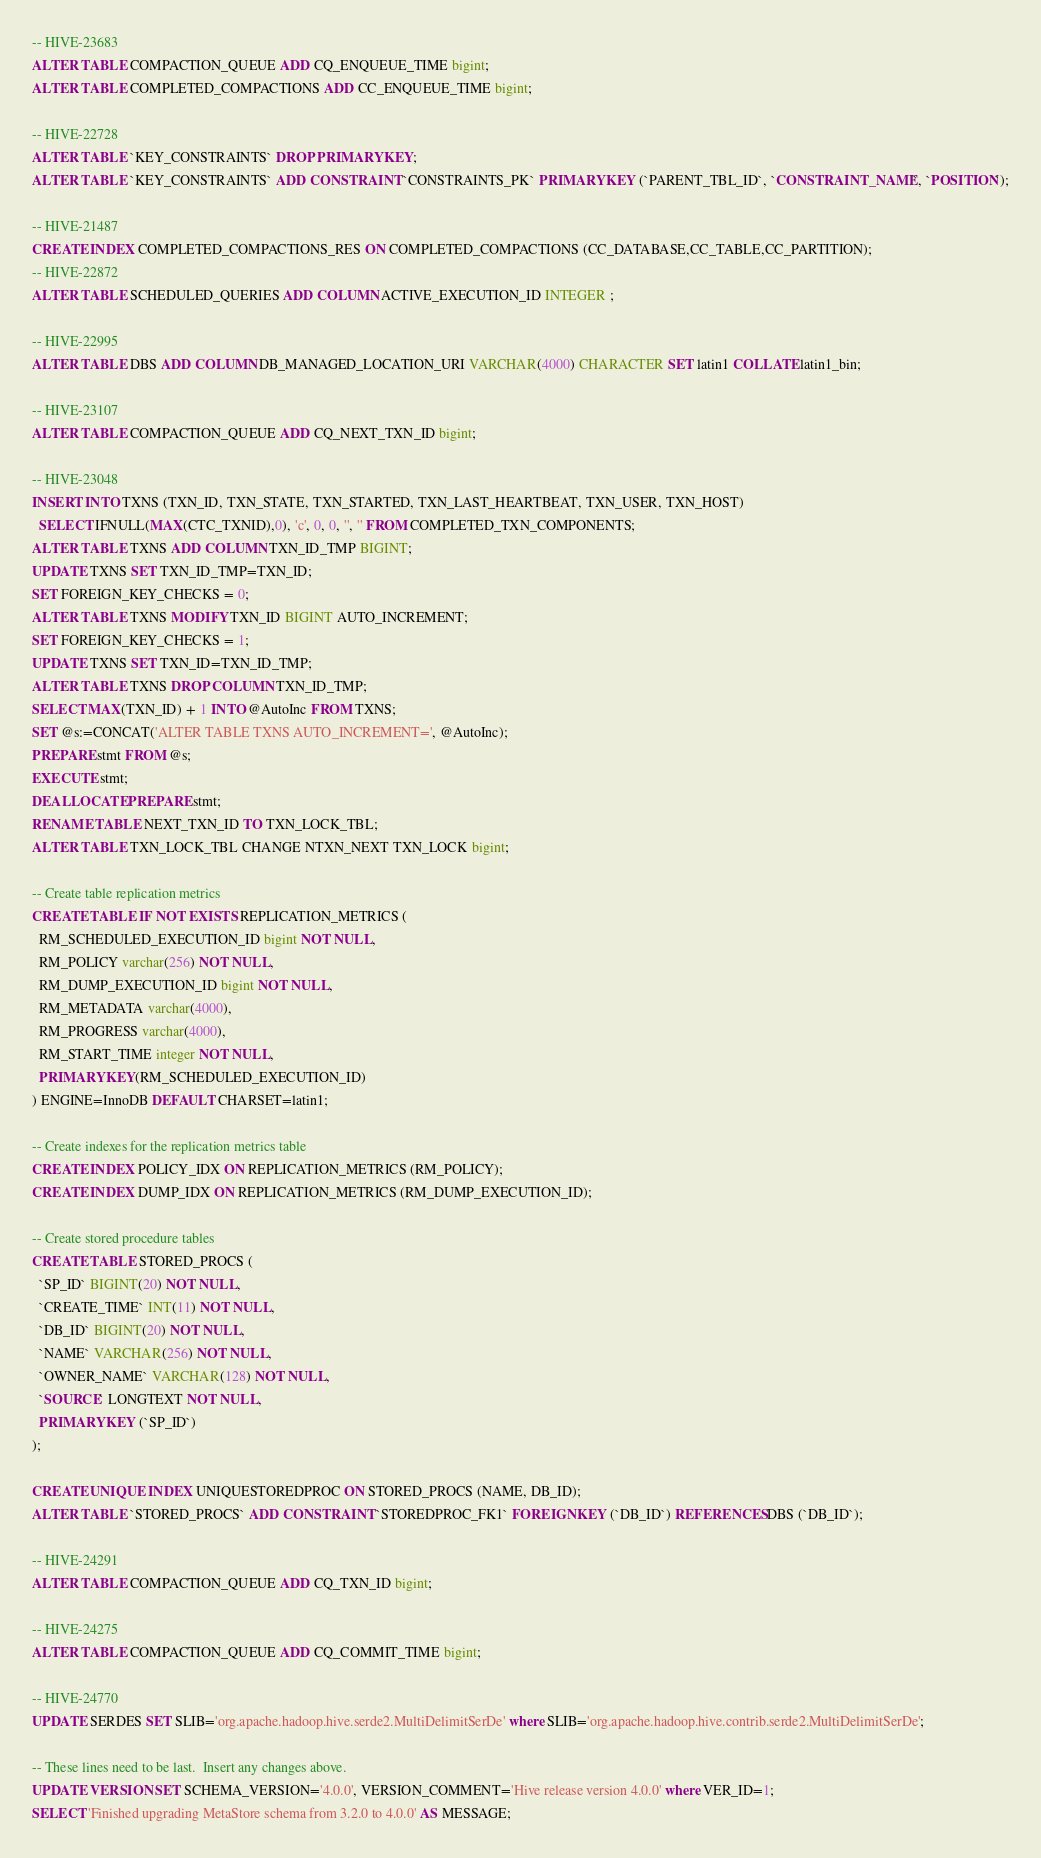<code> <loc_0><loc_0><loc_500><loc_500><_SQL_>-- HIVE-23683
ALTER TABLE COMPACTION_QUEUE ADD CQ_ENQUEUE_TIME bigint;
ALTER TABLE COMPLETED_COMPACTIONS ADD CC_ENQUEUE_TIME bigint;

-- HIVE-22728
ALTER TABLE `KEY_CONSTRAINTS` DROP PRIMARY KEY;
ALTER TABLE `KEY_CONSTRAINTS` ADD CONSTRAINT `CONSTRAINTS_PK` PRIMARY KEY (`PARENT_TBL_ID`, `CONSTRAINT_NAME`, `POSITION`);

-- HIVE-21487
CREATE INDEX COMPLETED_COMPACTIONS_RES ON COMPLETED_COMPACTIONS (CC_DATABASE,CC_TABLE,CC_PARTITION);
-- HIVE-22872
ALTER TABLE SCHEDULED_QUERIES ADD COLUMN ACTIVE_EXECUTION_ID INTEGER ;

-- HIVE-22995
ALTER TABLE DBS ADD COLUMN DB_MANAGED_LOCATION_URI VARCHAR(4000) CHARACTER SET latin1 COLLATE latin1_bin;

-- HIVE-23107
ALTER TABLE COMPACTION_QUEUE ADD CQ_NEXT_TXN_ID bigint;

-- HIVE-23048
INSERT INTO TXNS (TXN_ID, TXN_STATE, TXN_STARTED, TXN_LAST_HEARTBEAT, TXN_USER, TXN_HOST)
  SELECT IFNULL(MAX(CTC_TXNID),0), 'c', 0, 0, '', '' FROM COMPLETED_TXN_COMPONENTS;
ALTER TABLE TXNS ADD COLUMN TXN_ID_TMP BIGINT;
UPDATE TXNS SET TXN_ID_TMP=TXN_ID;
SET FOREIGN_KEY_CHECKS = 0;
ALTER TABLE TXNS MODIFY TXN_ID BIGINT AUTO_INCREMENT;
SET FOREIGN_KEY_CHECKS = 1;
UPDATE TXNS SET TXN_ID=TXN_ID_TMP;
ALTER TABLE TXNS DROP COLUMN TXN_ID_TMP;
SELECT MAX(TXN_ID) + 1 INTO @AutoInc FROM TXNS;
SET @s:=CONCAT('ALTER TABLE TXNS AUTO_INCREMENT=', @AutoInc);
PREPARE stmt FROM @s;
EXECUTE stmt;
DEALLOCATE PREPARE stmt;
RENAME TABLE NEXT_TXN_ID TO TXN_LOCK_TBL;
ALTER TABLE TXN_LOCK_TBL CHANGE NTXN_NEXT TXN_LOCK bigint;

-- Create table replication metrics
CREATE TABLE IF NOT EXISTS REPLICATION_METRICS (
  RM_SCHEDULED_EXECUTION_ID bigint NOT NULL,
  RM_POLICY varchar(256) NOT NULL,
  RM_DUMP_EXECUTION_ID bigint NOT NULL,
  RM_METADATA varchar(4000),
  RM_PROGRESS varchar(4000),
  RM_START_TIME integer NOT NULL,
  PRIMARY KEY(RM_SCHEDULED_EXECUTION_ID)
) ENGINE=InnoDB DEFAULT CHARSET=latin1;

-- Create indexes for the replication metrics table
CREATE INDEX POLICY_IDX ON REPLICATION_METRICS (RM_POLICY);
CREATE INDEX DUMP_IDX ON REPLICATION_METRICS (RM_DUMP_EXECUTION_ID);

-- Create stored procedure tables
CREATE TABLE STORED_PROCS (
  `SP_ID` BIGINT(20) NOT NULL,
  `CREATE_TIME` INT(11) NOT NULL,
  `DB_ID` BIGINT(20) NOT NULL,
  `NAME` VARCHAR(256) NOT NULL,
  `OWNER_NAME` VARCHAR(128) NOT NULL,
  `SOURCE` LONGTEXT NOT NULL,
  PRIMARY KEY (`SP_ID`)
);

CREATE UNIQUE INDEX UNIQUESTOREDPROC ON STORED_PROCS (NAME, DB_ID);
ALTER TABLE `STORED_PROCS` ADD CONSTRAINT `STOREDPROC_FK1` FOREIGN KEY (`DB_ID`) REFERENCES DBS (`DB_ID`);

-- HIVE-24291
ALTER TABLE COMPACTION_QUEUE ADD CQ_TXN_ID bigint;

-- HIVE-24275
ALTER TABLE COMPACTION_QUEUE ADD CQ_COMMIT_TIME bigint;

-- HIVE-24770
UPDATE SERDES SET SLIB='org.apache.hadoop.hive.serde2.MultiDelimitSerDe' where SLIB='org.apache.hadoop.hive.contrib.serde2.MultiDelimitSerDe';

-- These lines need to be last.  Insert any changes above.
UPDATE VERSION SET SCHEMA_VERSION='4.0.0', VERSION_COMMENT='Hive release version 4.0.0' where VER_ID=1;
SELECT 'Finished upgrading MetaStore schema from 3.2.0 to 4.0.0' AS MESSAGE;
</code> 